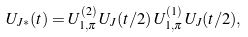Convert formula to latex. <formula><loc_0><loc_0><loc_500><loc_500>U _ { J * } ( t ) = U _ { 1 , \pi } ^ { ( 2 ) } \, U _ { J } ( t / 2 ) \, U _ { 1 , \pi } ^ { ( 1 ) } \, U _ { J } ( t / 2 ) ,</formula> 